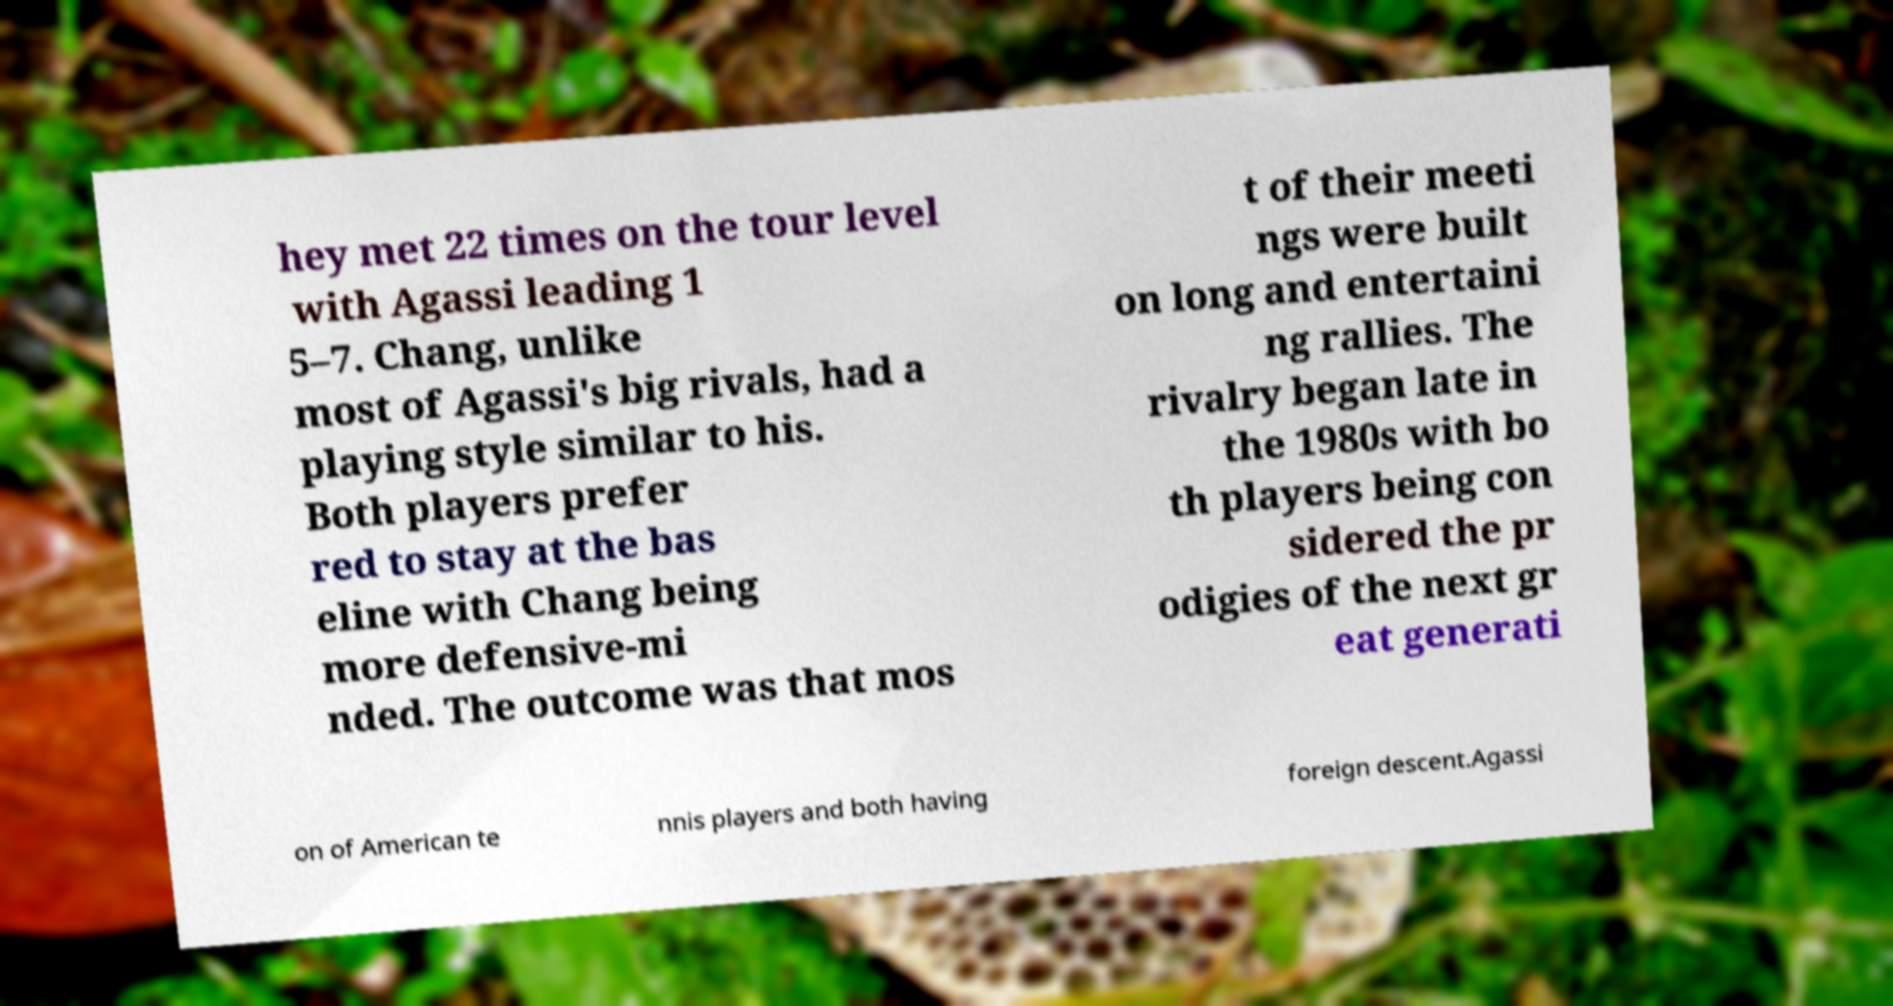Please read and relay the text visible in this image. What does it say? hey met 22 times on the tour level with Agassi leading 1 5–7. Chang, unlike most of Agassi's big rivals, had a playing style similar to his. Both players prefer red to stay at the bas eline with Chang being more defensive-mi nded. The outcome was that mos t of their meeti ngs were built on long and entertaini ng rallies. The rivalry began late in the 1980s with bo th players being con sidered the pr odigies of the next gr eat generati on of American te nnis players and both having foreign descent.Agassi 